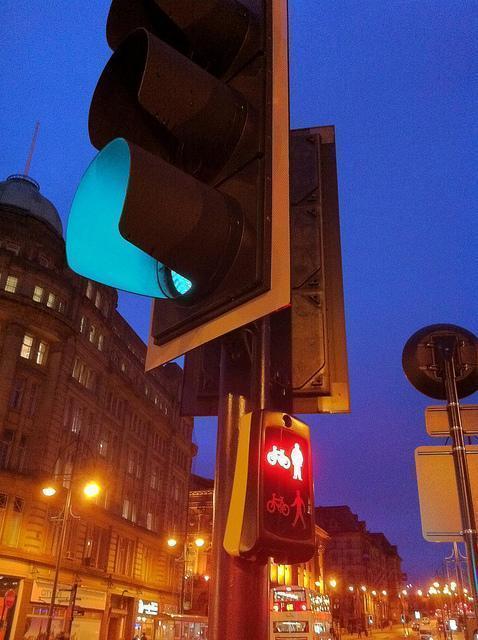What does the bottom red light prohibit?
Indicate the correct response by choosing from the four available options to answer the question.
Options: Loitering, crossing, trading, racing. Crossing. 